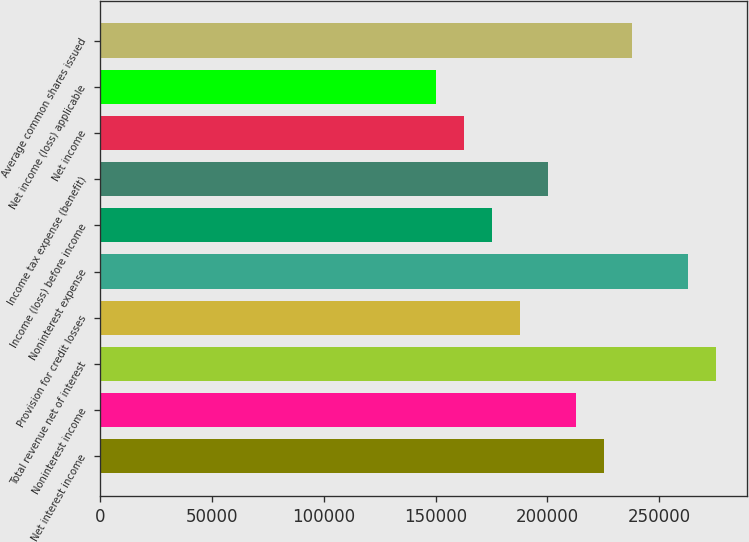Convert chart to OTSL. <chart><loc_0><loc_0><loc_500><loc_500><bar_chart><fcel>Net interest income<fcel>Noninterest income<fcel>Total revenue net of interest<fcel>Provision for credit losses<fcel>Noninterest expense<fcel>Income (loss) before income<fcel>Income tax expense (benefit)<fcel>Net income<fcel>Net income (loss) applicable<fcel>Average common shares issued<nl><fcel>225245<fcel>212731<fcel>275299<fcel>187704<fcel>262786<fcel>175190<fcel>200218<fcel>162677<fcel>150163<fcel>237758<nl></chart> 